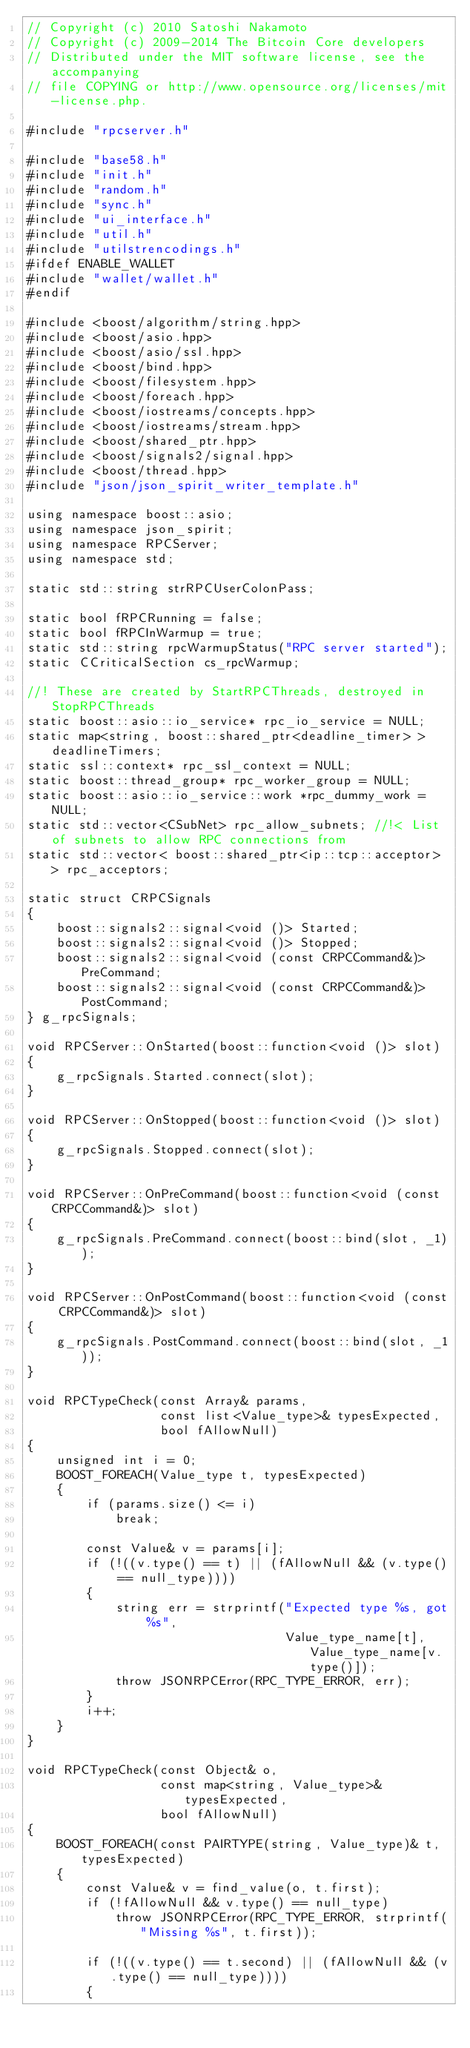<code> <loc_0><loc_0><loc_500><loc_500><_C++_>// Copyright (c) 2010 Satoshi Nakamoto
// Copyright (c) 2009-2014 The Bitcoin Core developers
// Distributed under the MIT software license, see the accompanying
// file COPYING or http://www.opensource.org/licenses/mit-license.php.

#include "rpcserver.h"

#include "base58.h"
#include "init.h"
#include "random.h"
#include "sync.h"
#include "ui_interface.h"
#include "util.h"
#include "utilstrencodings.h"
#ifdef ENABLE_WALLET
#include "wallet/wallet.h"
#endif

#include <boost/algorithm/string.hpp>
#include <boost/asio.hpp>
#include <boost/asio/ssl.hpp>
#include <boost/bind.hpp>
#include <boost/filesystem.hpp>
#include <boost/foreach.hpp>
#include <boost/iostreams/concepts.hpp>
#include <boost/iostreams/stream.hpp>
#include <boost/shared_ptr.hpp>
#include <boost/signals2/signal.hpp>
#include <boost/thread.hpp>
#include "json/json_spirit_writer_template.h"

using namespace boost::asio;
using namespace json_spirit;
using namespace RPCServer;
using namespace std;

static std::string strRPCUserColonPass;

static bool fRPCRunning = false;
static bool fRPCInWarmup = true;
static std::string rpcWarmupStatus("RPC server started");
static CCriticalSection cs_rpcWarmup;

//! These are created by StartRPCThreads, destroyed in StopRPCThreads
static boost::asio::io_service* rpc_io_service = NULL;
static map<string, boost::shared_ptr<deadline_timer> > deadlineTimers;
static ssl::context* rpc_ssl_context = NULL;
static boost::thread_group* rpc_worker_group = NULL;
static boost::asio::io_service::work *rpc_dummy_work = NULL;
static std::vector<CSubNet> rpc_allow_subnets; //!< List of subnets to allow RPC connections from
static std::vector< boost::shared_ptr<ip::tcp::acceptor> > rpc_acceptors;

static struct CRPCSignals
{
    boost::signals2::signal<void ()> Started;
    boost::signals2::signal<void ()> Stopped;
    boost::signals2::signal<void (const CRPCCommand&)> PreCommand;
    boost::signals2::signal<void (const CRPCCommand&)> PostCommand;
} g_rpcSignals;

void RPCServer::OnStarted(boost::function<void ()> slot)
{
    g_rpcSignals.Started.connect(slot);
}

void RPCServer::OnStopped(boost::function<void ()> slot)
{
    g_rpcSignals.Stopped.connect(slot);
}

void RPCServer::OnPreCommand(boost::function<void (const CRPCCommand&)> slot)
{
    g_rpcSignals.PreCommand.connect(boost::bind(slot, _1));
}

void RPCServer::OnPostCommand(boost::function<void (const CRPCCommand&)> slot)
{
    g_rpcSignals.PostCommand.connect(boost::bind(slot, _1));
}

void RPCTypeCheck(const Array& params,
                  const list<Value_type>& typesExpected,
                  bool fAllowNull)
{
    unsigned int i = 0;
    BOOST_FOREACH(Value_type t, typesExpected)
    {
        if (params.size() <= i)
            break;

        const Value& v = params[i];
        if (!((v.type() == t) || (fAllowNull && (v.type() == null_type))))
        {
            string err = strprintf("Expected type %s, got %s",
                                   Value_type_name[t], Value_type_name[v.type()]);
            throw JSONRPCError(RPC_TYPE_ERROR, err);
        }
        i++;
    }
}

void RPCTypeCheck(const Object& o,
                  const map<string, Value_type>& typesExpected,
                  bool fAllowNull)
{
    BOOST_FOREACH(const PAIRTYPE(string, Value_type)& t, typesExpected)
    {
        const Value& v = find_value(o, t.first);
        if (!fAllowNull && v.type() == null_type)
            throw JSONRPCError(RPC_TYPE_ERROR, strprintf("Missing %s", t.first));

        if (!((v.type() == t.second) || (fAllowNull && (v.type() == null_type))))
        {</code> 